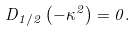<formula> <loc_0><loc_0><loc_500><loc_500>D _ { 1 / 2 } \left ( - \kappa ^ { 2 } \right ) = 0 .</formula> 